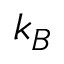<formula> <loc_0><loc_0><loc_500><loc_500>k _ { B }</formula> 